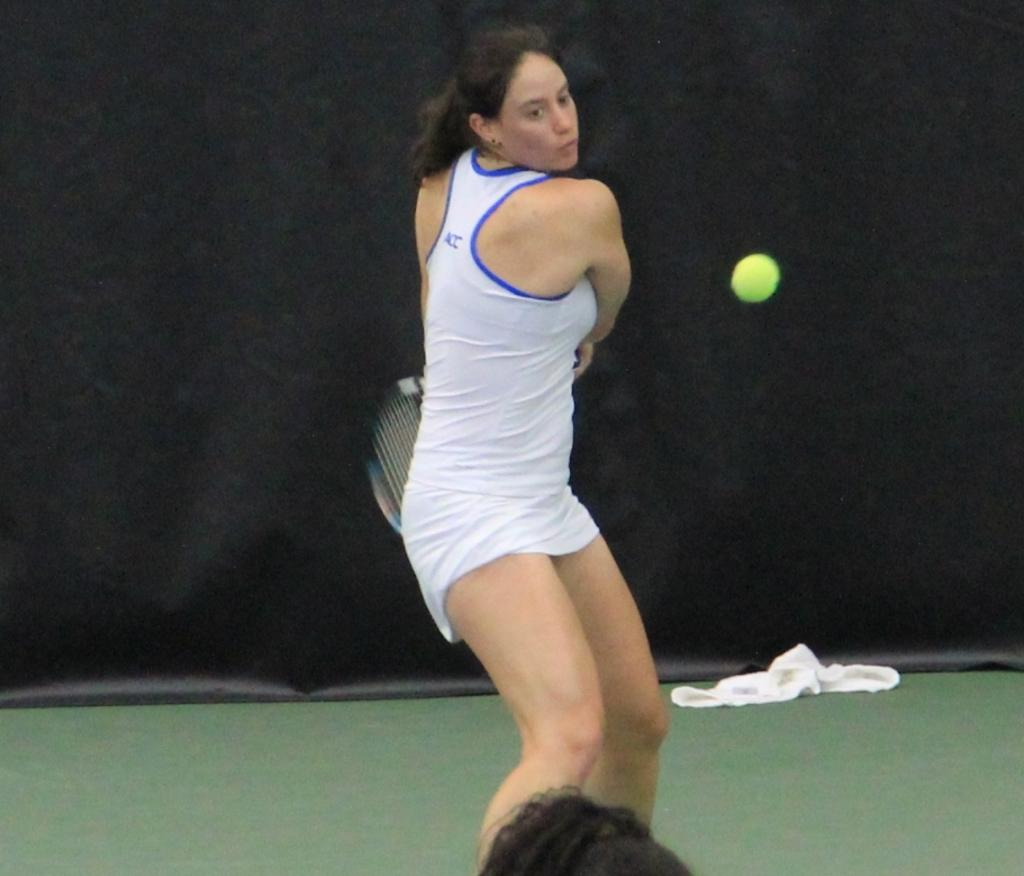Who is the main subject in the image? There is a woman in the image. What is the woman doing in the image? The woman is standing on the ground and playing with a ball. What object is the woman holding in her hands? The woman is holding a racket in her hands. What credit score does the woman have in the image? There is no information about the woman's credit score in the image. What historical event is depicted in the image? There is no historical event depicted in the image; it shows a woman playing with a ball and holding a racket. 